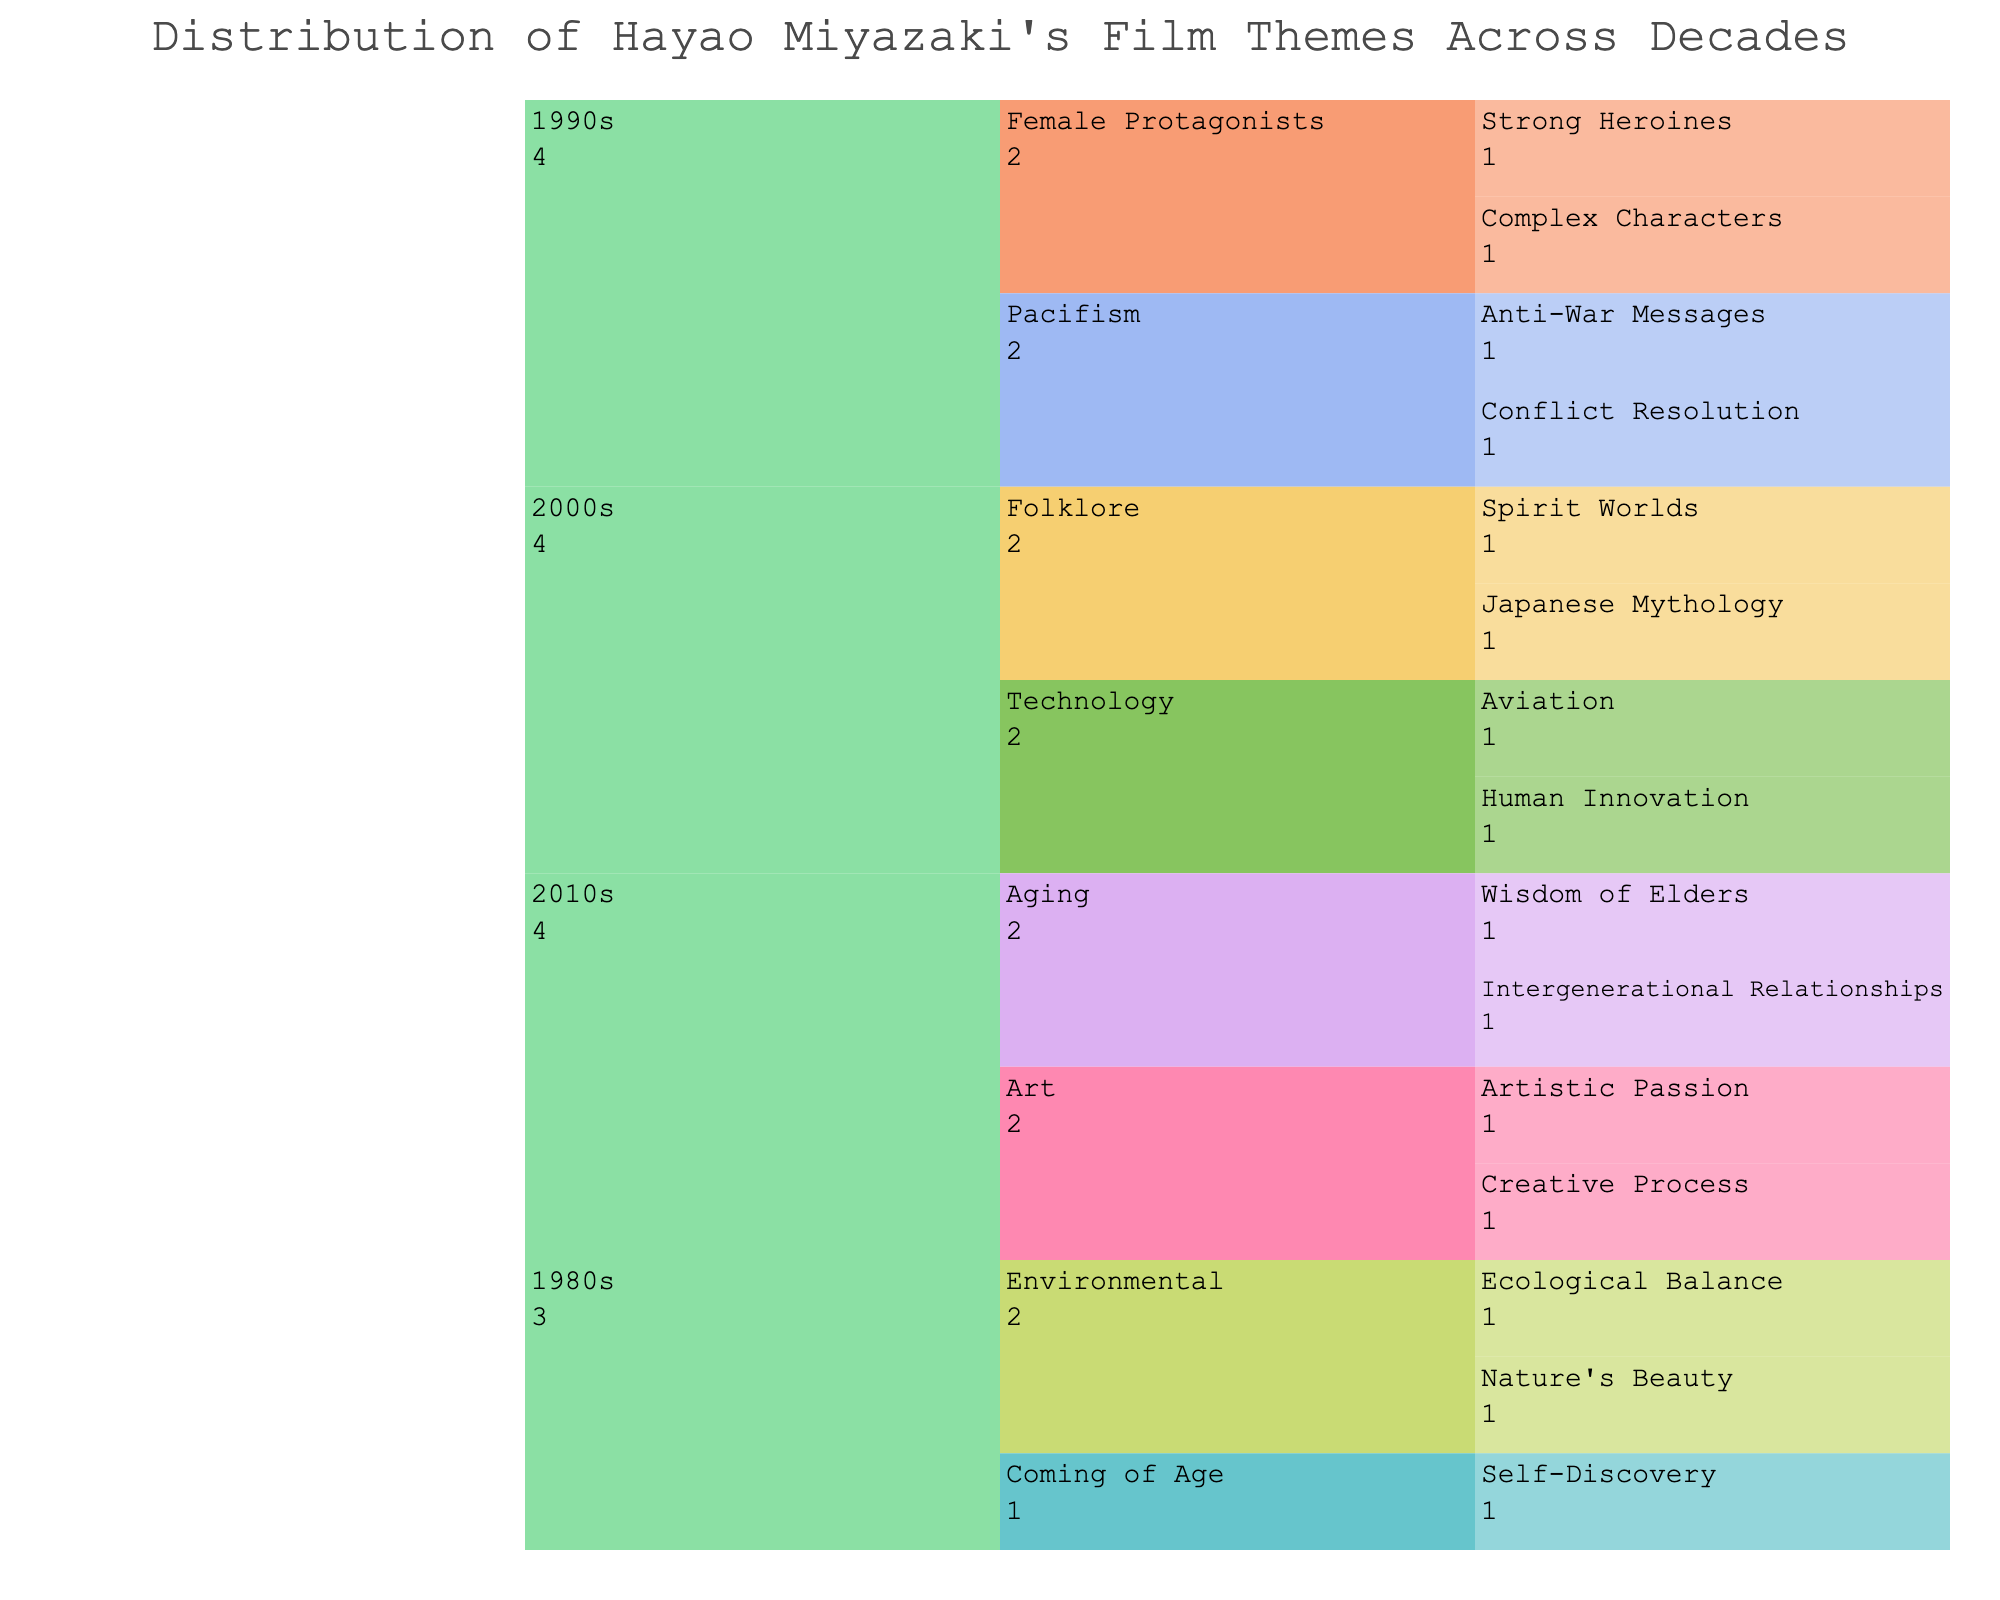What is the title of the chart? The title is located at the top of the chart.
Answer: Distribution of Hayao Miyazaki's Film Themes Across Decades Which decade has the most subthemes listed? The chart shows subthemes under each decade. The 1990s have four subthemes listed, more than any other decade.
Answer: 1990s How many main themes are represented in the 2000s? Count the main themes directly under the 2000s node. There are two themes: Folklore and Technology.
Answer: 2 Which theme is associated with "Intergenerational Relationships"? Locate "Intergenerational Relationships" and trace it up to its parent theme. It falls under the theme "Aging".
Answer: Aging What subtheme does "Japanese Mythology" fall under in the 2000s? Find "Japanese Mythology" in the 2000s section and trace its parent theme. It is under "Folklore".
Answer: Folklore What are the subthemes under "Female Protagonists" in the 1990s? Look for the "Female Protagonists" theme in the 1990s and list its subthemes directly under it. These are "Strong Heroines" and "Complex Characters".
Answer: Strong Heroines, Complex Characters How many subthemes are there in total across all decades? Count all the subthemes listed under each theme for all decades. There are 14 in total.
Answer: 14 Which theme from the 2010s does "Creative Process" belong to? Locate "Creative Process" in the 2010s section and identify its parent theme. It belongs to "Art".
Answer: Art How does the count of subthemes in the 1980s compare to those in the 2000s? Count the subthemes in both decades. The 1980s have three subthemes, while the 2000s have four, showing the 2000s have one more subtheme than the 1980s.
Answer: 2000s has one more Is "Aviation" considered a subtheme under "Technology"? Locate "Aviation" and see if it is nested under "Technology". It is indeed a subtheme of "Technology".
Answer: Yes 